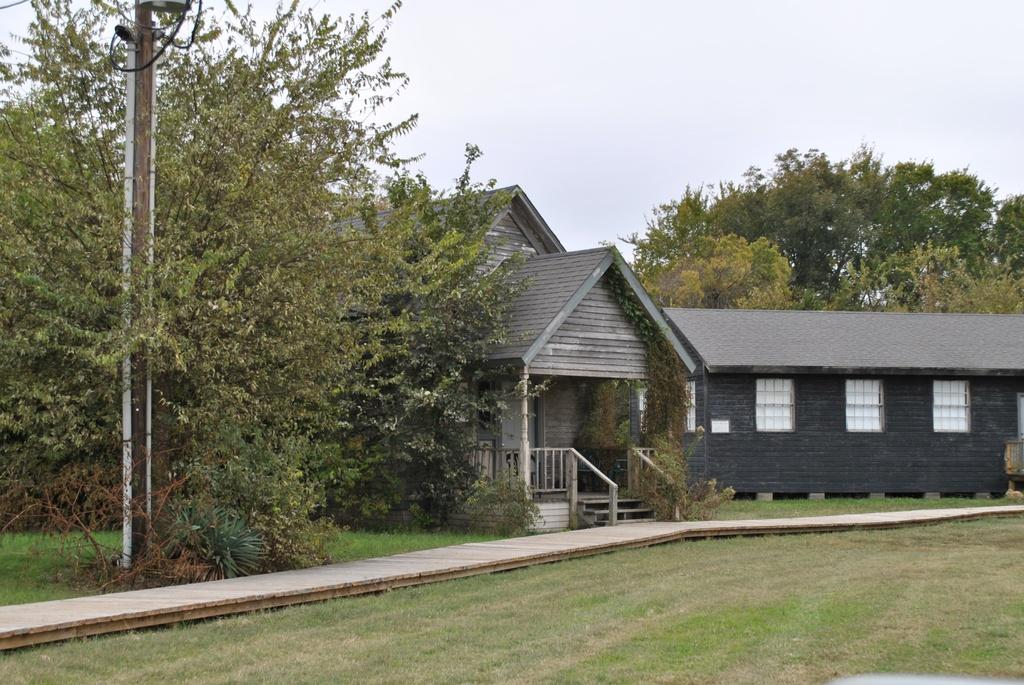What type of structure is visible in the image? There is a house in the image. What is located beside the house? There are trees beside the house. What else can be seen in the image? There is a pole in the image. How is the land around the house described? The land is covered with grass. What is the condition of the sky in the image? The sky is cloudy. What features does the house have? The house has windows and a door. What type of noise can be heard coming from the meeting in the image? There is no meeting present in the image, so no noise can be heard from it. 